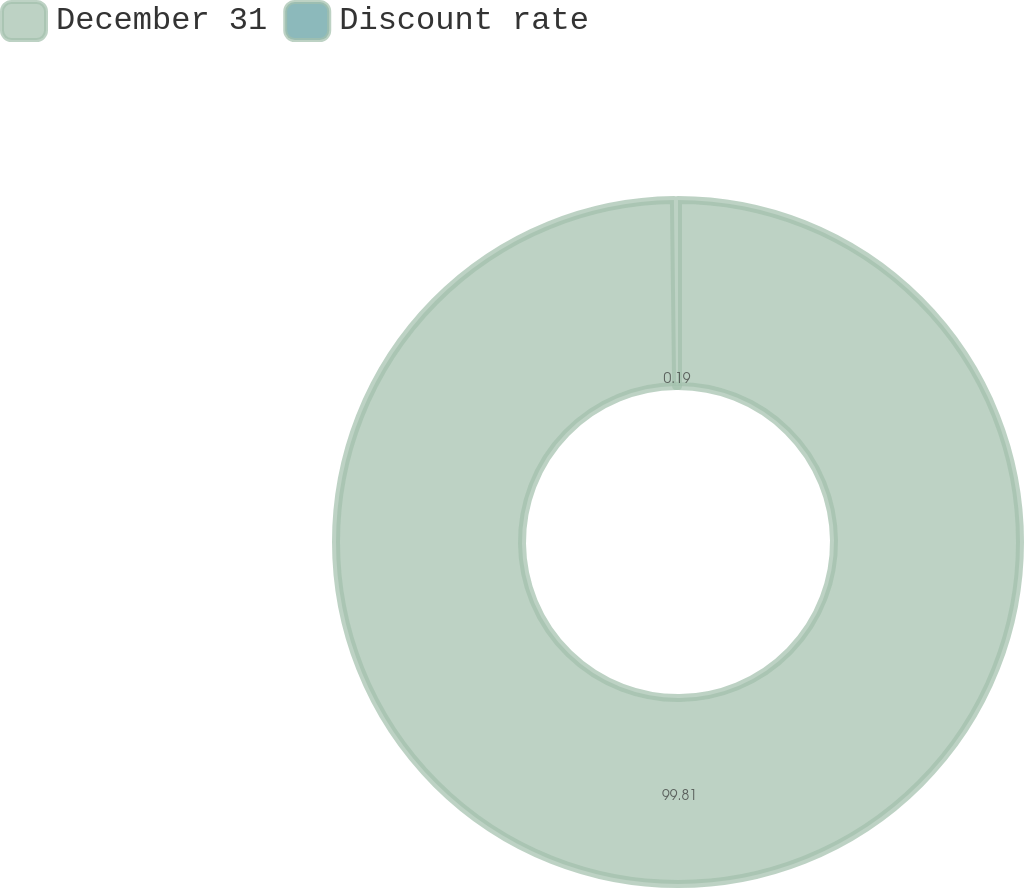Convert chart. <chart><loc_0><loc_0><loc_500><loc_500><pie_chart><fcel>December 31<fcel>Discount rate<nl><fcel>99.81%<fcel>0.19%<nl></chart> 